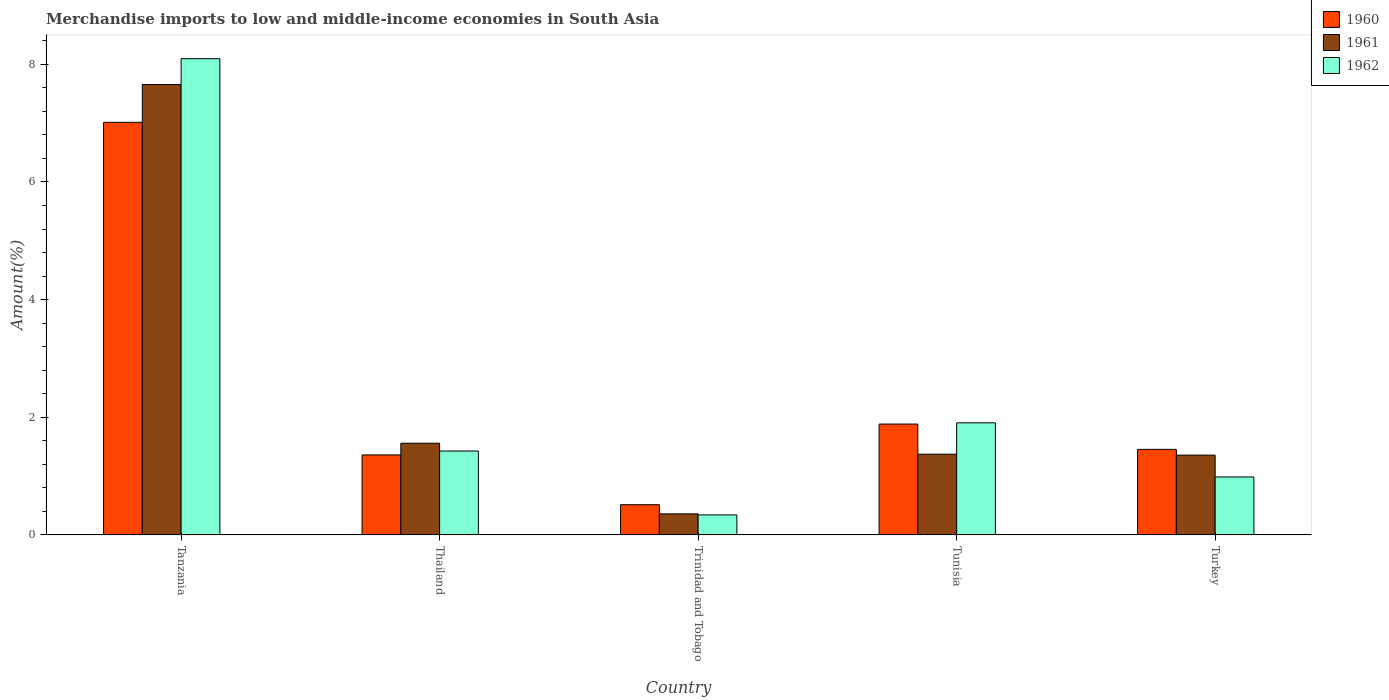How many different coloured bars are there?
Offer a terse response. 3. How many groups of bars are there?
Give a very brief answer. 5. Are the number of bars on each tick of the X-axis equal?
Offer a terse response. Yes. How many bars are there on the 2nd tick from the right?
Offer a very short reply. 3. In how many cases, is the number of bars for a given country not equal to the number of legend labels?
Provide a short and direct response. 0. What is the percentage of amount earned from merchandise imports in 1961 in Tanzania?
Provide a succinct answer. 7.66. Across all countries, what is the maximum percentage of amount earned from merchandise imports in 1962?
Keep it short and to the point. 8.1. Across all countries, what is the minimum percentage of amount earned from merchandise imports in 1962?
Keep it short and to the point. 0.34. In which country was the percentage of amount earned from merchandise imports in 1961 maximum?
Your answer should be compact. Tanzania. In which country was the percentage of amount earned from merchandise imports in 1962 minimum?
Provide a succinct answer. Trinidad and Tobago. What is the total percentage of amount earned from merchandise imports in 1961 in the graph?
Make the answer very short. 12.3. What is the difference between the percentage of amount earned from merchandise imports in 1962 in Tanzania and that in Trinidad and Tobago?
Keep it short and to the point. 7.76. What is the difference between the percentage of amount earned from merchandise imports in 1961 in Trinidad and Tobago and the percentage of amount earned from merchandise imports in 1962 in Turkey?
Offer a very short reply. -0.63. What is the average percentage of amount earned from merchandise imports in 1961 per country?
Give a very brief answer. 2.46. What is the difference between the percentage of amount earned from merchandise imports of/in 1961 and percentage of amount earned from merchandise imports of/in 1960 in Thailand?
Give a very brief answer. 0.2. What is the ratio of the percentage of amount earned from merchandise imports in 1960 in Thailand to that in Tunisia?
Keep it short and to the point. 0.72. Is the percentage of amount earned from merchandise imports in 1961 in Tanzania less than that in Tunisia?
Provide a succinct answer. No. Is the difference between the percentage of amount earned from merchandise imports in 1961 in Thailand and Tunisia greater than the difference between the percentage of amount earned from merchandise imports in 1960 in Thailand and Tunisia?
Provide a succinct answer. Yes. What is the difference between the highest and the second highest percentage of amount earned from merchandise imports in 1961?
Your answer should be compact. 0.19. What is the difference between the highest and the lowest percentage of amount earned from merchandise imports in 1962?
Provide a short and direct response. 7.76. Is it the case that in every country, the sum of the percentage of amount earned from merchandise imports in 1960 and percentage of amount earned from merchandise imports in 1961 is greater than the percentage of amount earned from merchandise imports in 1962?
Offer a very short reply. Yes. Are all the bars in the graph horizontal?
Give a very brief answer. No. How many countries are there in the graph?
Make the answer very short. 5. Does the graph contain any zero values?
Provide a succinct answer. No. Where does the legend appear in the graph?
Offer a terse response. Top right. How many legend labels are there?
Your response must be concise. 3. What is the title of the graph?
Provide a succinct answer. Merchandise imports to low and middle-income economies in South Asia. What is the label or title of the Y-axis?
Your answer should be very brief. Amount(%). What is the Amount(%) in 1960 in Tanzania?
Ensure brevity in your answer.  7.01. What is the Amount(%) of 1961 in Tanzania?
Provide a short and direct response. 7.66. What is the Amount(%) of 1962 in Tanzania?
Offer a very short reply. 8.1. What is the Amount(%) in 1960 in Thailand?
Keep it short and to the point. 1.36. What is the Amount(%) of 1961 in Thailand?
Your response must be concise. 1.56. What is the Amount(%) of 1962 in Thailand?
Provide a succinct answer. 1.43. What is the Amount(%) in 1960 in Trinidad and Tobago?
Offer a very short reply. 0.51. What is the Amount(%) of 1961 in Trinidad and Tobago?
Give a very brief answer. 0.36. What is the Amount(%) of 1962 in Trinidad and Tobago?
Ensure brevity in your answer.  0.34. What is the Amount(%) of 1960 in Tunisia?
Your answer should be compact. 1.88. What is the Amount(%) in 1961 in Tunisia?
Your answer should be compact. 1.37. What is the Amount(%) in 1962 in Tunisia?
Provide a short and direct response. 1.91. What is the Amount(%) in 1960 in Turkey?
Your answer should be very brief. 1.45. What is the Amount(%) of 1961 in Turkey?
Offer a very short reply. 1.36. What is the Amount(%) in 1962 in Turkey?
Offer a very short reply. 0.98. Across all countries, what is the maximum Amount(%) of 1960?
Your response must be concise. 7.01. Across all countries, what is the maximum Amount(%) in 1961?
Provide a succinct answer. 7.66. Across all countries, what is the maximum Amount(%) of 1962?
Provide a short and direct response. 8.1. Across all countries, what is the minimum Amount(%) of 1960?
Offer a terse response. 0.51. Across all countries, what is the minimum Amount(%) in 1961?
Offer a terse response. 0.36. Across all countries, what is the minimum Amount(%) in 1962?
Ensure brevity in your answer.  0.34. What is the total Amount(%) in 1960 in the graph?
Your response must be concise. 12.22. What is the total Amount(%) of 1961 in the graph?
Offer a very short reply. 12.3. What is the total Amount(%) in 1962 in the graph?
Offer a very short reply. 12.75. What is the difference between the Amount(%) in 1960 in Tanzania and that in Thailand?
Offer a terse response. 5.65. What is the difference between the Amount(%) of 1961 in Tanzania and that in Thailand?
Give a very brief answer. 6.1. What is the difference between the Amount(%) of 1962 in Tanzania and that in Thailand?
Provide a succinct answer. 6.67. What is the difference between the Amount(%) of 1960 in Tanzania and that in Trinidad and Tobago?
Your answer should be compact. 6.5. What is the difference between the Amount(%) of 1961 in Tanzania and that in Trinidad and Tobago?
Keep it short and to the point. 7.3. What is the difference between the Amount(%) of 1962 in Tanzania and that in Trinidad and Tobago?
Keep it short and to the point. 7.76. What is the difference between the Amount(%) of 1960 in Tanzania and that in Tunisia?
Offer a terse response. 5.13. What is the difference between the Amount(%) of 1961 in Tanzania and that in Tunisia?
Provide a short and direct response. 6.28. What is the difference between the Amount(%) in 1962 in Tanzania and that in Tunisia?
Your response must be concise. 6.19. What is the difference between the Amount(%) of 1960 in Tanzania and that in Turkey?
Make the answer very short. 5.56. What is the difference between the Amount(%) of 1961 in Tanzania and that in Turkey?
Ensure brevity in your answer.  6.3. What is the difference between the Amount(%) of 1962 in Tanzania and that in Turkey?
Ensure brevity in your answer.  7.11. What is the difference between the Amount(%) in 1960 in Thailand and that in Trinidad and Tobago?
Offer a very short reply. 0.85. What is the difference between the Amount(%) in 1961 in Thailand and that in Trinidad and Tobago?
Keep it short and to the point. 1.2. What is the difference between the Amount(%) in 1962 in Thailand and that in Trinidad and Tobago?
Keep it short and to the point. 1.09. What is the difference between the Amount(%) in 1960 in Thailand and that in Tunisia?
Give a very brief answer. -0.52. What is the difference between the Amount(%) in 1961 in Thailand and that in Tunisia?
Your response must be concise. 0.19. What is the difference between the Amount(%) of 1962 in Thailand and that in Tunisia?
Provide a succinct answer. -0.48. What is the difference between the Amount(%) of 1960 in Thailand and that in Turkey?
Give a very brief answer. -0.09. What is the difference between the Amount(%) of 1961 in Thailand and that in Turkey?
Provide a succinct answer. 0.2. What is the difference between the Amount(%) of 1962 in Thailand and that in Turkey?
Your answer should be compact. 0.44. What is the difference between the Amount(%) in 1960 in Trinidad and Tobago and that in Tunisia?
Your response must be concise. -1.37. What is the difference between the Amount(%) of 1961 in Trinidad and Tobago and that in Tunisia?
Your response must be concise. -1.01. What is the difference between the Amount(%) of 1962 in Trinidad and Tobago and that in Tunisia?
Keep it short and to the point. -1.57. What is the difference between the Amount(%) in 1960 in Trinidad and Tobago and that in Turkey?
Provide a short and direct response. -0.94. What is the difference between the Amount(%) in 1961 in Trinidad and Tobago and that in Turkey?
Ensure brevity in your answer.  -1. What is the difference between the Amount(%) of 1962 in Trinidad and Tobago and that in Turkey?
Provide a succinct answer. -0.65. What is the difference between the Amount(%) of 1960 in Tunisia and that in Turkey?
Your answer should be compact. 0.43. What is the difference between the Amount(%) of 1961 in Tunisia and that in Turkey?
Your answer should be very brief. 0.02. What is the difference between the Amount(%) of 1962 in Tunisia and that in Turkey?
Offer a very short reply. 0.92. What is the difference between the Amount(%) in 1960 in Tanzania and the Amount(%) in 1961 in Thailand?
Provide a short and direct response. 5.45. What is the difference between the Amount(%) of 1960 in Tanzania and the Amount(%) of 1962 in Thailand?
Offer a terse response. 5.59. What is the difference between the Amount(%) in 1961 in Tanzania and the Amount(%) in 1962 in Thailand?
Ensure brevity in your answer.  6.23. What is the difference between the Amount(%) of 1960 in Tanzania and the Amount(%) of 1961 in Trinidad and Tobago?
Your answer should be compact. 6.66. What is the difference between the Amount(%) of 1960 in Tanzania and the Amount(%) of 1962 in Trinidad and Tobago?
Your answer should be compact. 6.67. What is the difference between the Amount(%) in 1961 in Tanzania and the Amount(%) in 1962 in Trinidad and Tobago?
Ensure brevity in your answer.  7.32. What is the difference between the Amount(%) in 1960 in Tanzania and the Amount(%) in 1961 in Tunisia?
Ensure brevity in your answer.  5.64. What is the difference between the Amount(%) in 1960 in Tanzania and the Amount(%) in 1962 in Tunisia?
Your response must be concise. 5.11. What is the difference between the Amount(%) in 1961 in Tanzania and the Amount(%) in 1962 in Tunisia?
Offer a very short reply. 5.75. What is the difference between the Amount(%) of 1960 in Tanzania and the Amount(%) of 1961 in Turkey?
Offer a terse response. 5.66. What is the difference between the Amount(%) in 1960 in Tanzania and the Amount(%) in 1962 in Turkey?
Provide a succinct answer. 6.03. What is the difference between the Amount(%) in 1961 in Tanzania and the Amount(%) in 1962 in Turkey?
Provide a short and direct response. 6.67. What is the difference between the Amount(%) in 1960 in Thailand and the Amount(%) in 1962 in Trinidad and Tobago?
Your response must be concise. 1.02. What is the difference between the Amount(%) of 1961 in Thailand and the Amount(%) of 1962 in Trinidad and Tobago?
Provide a succinct answer. 1.22. What is the difference between the Amount(%) of 1960 in Thailand and the Amount(%) of 1961 in Tunisia?
Ensure brevity in your answer.  -0.01. What is the difference between the Amount(%) of 1960 in Thailand and the Amount(%) of 1962 in Tunisia?
Offer a very short reply. -0.55. What is the difference between the Amount(%) of 1961 in Thailand and the Amount(%) of 1962 in Tunisia?
Your answer should be compact. -0.35. What is the difference between the Amount(%) in 1960 in Thailand and the Amount(%) in 1961 in Turkey?
Offer a terse response. 0. What is the difference between the Amount(%) in 1960 in Thailand and the Amount(%) in 1962 in Turkey?
Offer a very short reply. 0.37. What is the difference between the Amount(%) of 1961 in Thailand and the Amount(%) of 1962 in Turkey?
Give a very brief answer. 0.57. What is the difference between the Amount(%) in 1960 in Trinidad and Tobago and the Amount(%) in 1961 in Tunisia?
Your answer should be compact. -0.86. What is the difference between the Amount(%) of 1960 in Trinidad and Tobago and the Amount(%) of 1962 in Tunisia?
Give a very brief answer. -1.39. What is the difference between the Amount(%) of 1961 in Trinidad and Tobago and the Amount(%) of 1962 in Tunisia?
Your answer should be compact. -1.55. What is the difference between the Amount(%) in 1960 in Trinidad and Tobago and the Amount(%) in 1961 in Turkey?
Your answer should be very brief. -0.84. What is the difference between the Amount(%) in 1960 in Trinidad and Tobago and the Amount(%) in 1962 in Turkey?
Offer a terse response. -0.47. What is the difference between the Amount(%) in 1961 in Trinidad and Tobago and the Amount(%) in 1962 in Turkey?
Give a very brief answer. -0.63. What is the difference between the Amount(%) of 1960 in Tunisia and the Amount(%) of 1961 in Turkey?
Your response must be concise. 0.53. What is the difference between the Amount(%) in 1960 in Tunisia and the Amount(%) in 1962 in Turkey?
Your response must be concise. 0.9. What is the difference between the Amount(%) of 1961 in Tunisia and the Amount(%) of 1962 in Turkey?
Your response must be concise. 0.39. What is the average Amount(%) of 1960 per country?
Your response must be concise. 2.44. What is the average Amount(%) in 1961 per country?
Your response must be concise. 2.46. What is the average Amount(%) of 1962 per country?
Your answer should be compact. 2.55. What is the difference between the Amount(%) of 1960 and Amount(%) of 1961 in Tanzania?
Give a very brief answer. -0.64. What is the difference between the Amount(%) of 1960 and Amount(%) of 1962 in Tanzania?
Provide a succinct answer. -1.08. What is the difference between the Amount(%) in 1961 and Amount(%) in 1962 in Tanzania?
Give a very brief answer. -0.44. What is the difference between the Amount(%) in 1960 and Amount(%) in 1961 in Thailand?
Offer a terse response. -0.2. What is the difference between the Amount(%) in 1960 and Amount(%) in 1962 in Thailand?
Offer a terse response. -0.07. What is the difference between the Amount(%) of 1961 and Amount(%) of 1962 in Thailand?
Offer a very short reply. 0.13. What is the difference between the Amount(%) of 1960 and Amount(%) of 1961 in Trinidad and Tobago?
Provide a short and direct response. 0.16. What is the difference between the Amount(%) of 1960 and Amount(%) of 1962 in Trinidad and Tobago?
Your answer should be very brief. 0.17. What is the difference between the Amount(%) in 1961 and Amount(%) in 1962 in Trinidad and Tobago?
Your answer should be compact. 0.02. What is the difference between the Amount(%) of 1960 and Amount(%) of 1961 in Tunisia?
Provide a short and direct response. 0.51. What is the difference between the Amount(%) in 1960 and Amount(%) in 1962 in Tunisia?
Keep it short and to the point. -0.02. What is the difference between the Amount(%) of 1961 and Amount(%) of 1962 in Tunisia?
Provide a short and direct response. -0.53. What is the difference between the Amount(%) in 1960 and Amount(%) in 1961 in Turkey?
Offer a very short reply. 0.1. What is the difference between the Amount(%) in 1960 and Amount(%) in 1962 in Turkey?
Offer a terse response. 0.47. What is the difference between the Amount(%) in 1961 and Amount(%) in 1962 in Turkey?
Make the answer very short. 0.37. What is the ratio of the Amount(%) of 1960 in Tanzania to that in Thailand?
Offer a very short reply. 5.16. What is the ratio of the Amount(%) of 1961 in Tanzania to that in Thailand?
Provide a succinct answer. 4.91. What is the ratio of the Amount(%) of 1962 in Tanzania to that in Thailand?
Give a very brief answer. 5.68. What is the ratio of the Amount(%) in 1960 in Tanzania to that in Trinidad and Tobago?
Provide a short and direct response. 13.67. What is the ratio of the Amount(%) in 1961 in Tanzania to that in Trinidad and Tobago?
Keep it short and to the point. 21.42. What is the ratio of the Amount(%) of 1962 in Tanzania to that in Trinidad and Tobago?
Give a very brief answer. 23.83. What is the ratio of the Amount(%) of 1960 in Tanzania to that in Tunisia?
Provide a succinct answer. 3.72. What is the ratio of the Amount(%) of 1961 in Tanzania to that in Tunisia?
Your answer should be compact. 5.58. What is the ratio of the Amount(%) of 1962 in Tanzania to that in Tunisia?
Provide a succinct answer. 4.25. What is the ratio of the Amount(%) of 1960 in Tanzania to that in Turkey?
Keep it short and to the point. 4.82. What is the ratio of the Amount(%) in 1961 in Tanzania to that in Turkey?
Provide a succinct answer. 5.65. What is the ratio of the Amount(%) in 1962 in Tanzania to that in Turkey?
Offer a very short reply. 8.22. What is the ratio of the Amount(%) in 1960 in Thailand to that in Trinidad and Tobago?
Provide a succinct answer. 2.65. What is the ratio of the Amount(%) in 1961 in Thailand to that in Trinidad and Tobago?
Offer a very short reply. 4.36. What is the ratio of the Amount(%) in 1962 in Thailand to that in Trinidad and Tobago?
Ensure brevity in your answer.  4.2. What is the ratio of the Amount(%) in 1960 in Thailand to that in Tunisia?
Offer a very short reply. 0.72. What is the ratio of the Amount(%) of 1961 in Thailand to that in Tunisia?
Keep it short and to the point. 1.14. What is the ratio of the Amount(%) of 1962 in Thailand to that in Tunisia?
Your answer should be compact. 0.75. What is the ratio of the Amount(%) of 1960 in Thailand to that in Turkey?
Make the answer very short. 0.94. What is the ratio of the Amount(%) of 1961 in Thailand to that in Turkey?
Ensure brevity in your answer.  1.15. What is the ratio of the Amount(%) of 1962 in Thailand to that in Turkey?
Your answer should be compact. 1.45. What is the ratio of the Amount(%) of 1960 in Trinidad and Tobago to that in Tunisia?
Give a very brief answer. 0.27. What is the ratio of the Amount(%) in 1961 in Trinidad and Tobago to that in Tunisia?
Give a very brief answer. 0.26. What is the ratio of the Amount(%) of 1962 in Trinidad and Tobago to that in Tunisia?
Offer a very short reply. 0.18. What is the ratio of the Amount(%) of 1960 in Trinidad and Tobago to that in Turkey?
Your answer should be compact. 0.35. What is the ratio of the Amount(%) of 1961 in Trinidad and Tobago to that in Turkey?
Offer a terse response. 0.26. What is the ratio of the Amount(%) in 1962 in Trinidad and Tobago to that in Turkey?
Offer a very short reply. 0.34. What is the ratio of the Amount(%) of 1960 in Tunisia to that in Turkey?
Provide a succinct answer. 1.3. What is the ratio of the Amount(%) of 1961 in Tunisia to that in Turkey?
Give a very brief answer. 1.01. What is the ratio of the Amount(%) in 1962 in Tunisia to that in Turkey?
Offer a very short reply. 1.93. What is the difference between the highest and the second highest Amount(%) in 1960?
Your answer should be very brief. 5.13. What is the difference between the highest and the second highest Amount(%) in 1961?
Your answer should be compact. 6.1. What is the difference between the highest and the second highest Amount(%) of 1962?
Offer a terse response. 6.19. What is the difference between the highest and the lowest Amount(%) in 1960?
Give a very brief answer. 6.5. What is the difference between the highest and the lowest Amount(%) in 1961?
Ensure brevity in your answer.  7.3. What is the difference between the highest and the lowest Amount(%) of 1962?
Offer a terse response. 7.76. 